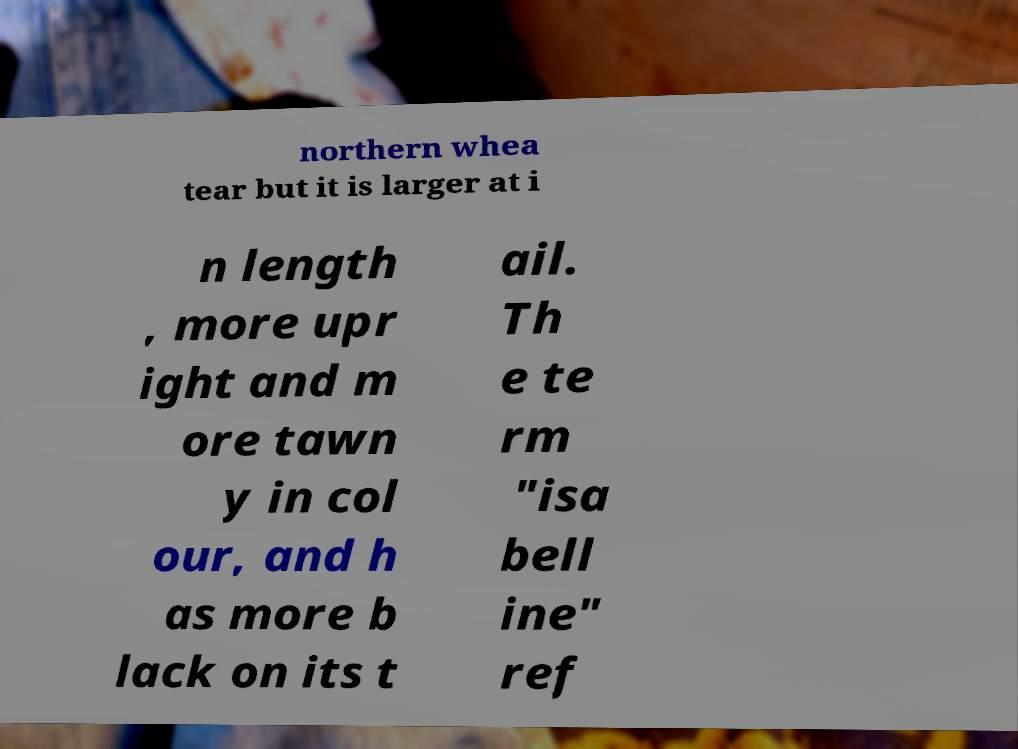Can you accurately transcribe the text from the provided image for me? northern whea tear but it is larger at i n length , more upr ight and m ore tawn y in col our, and h as more b lack on its t ail. Th e te rm "isa bell ine" ref 